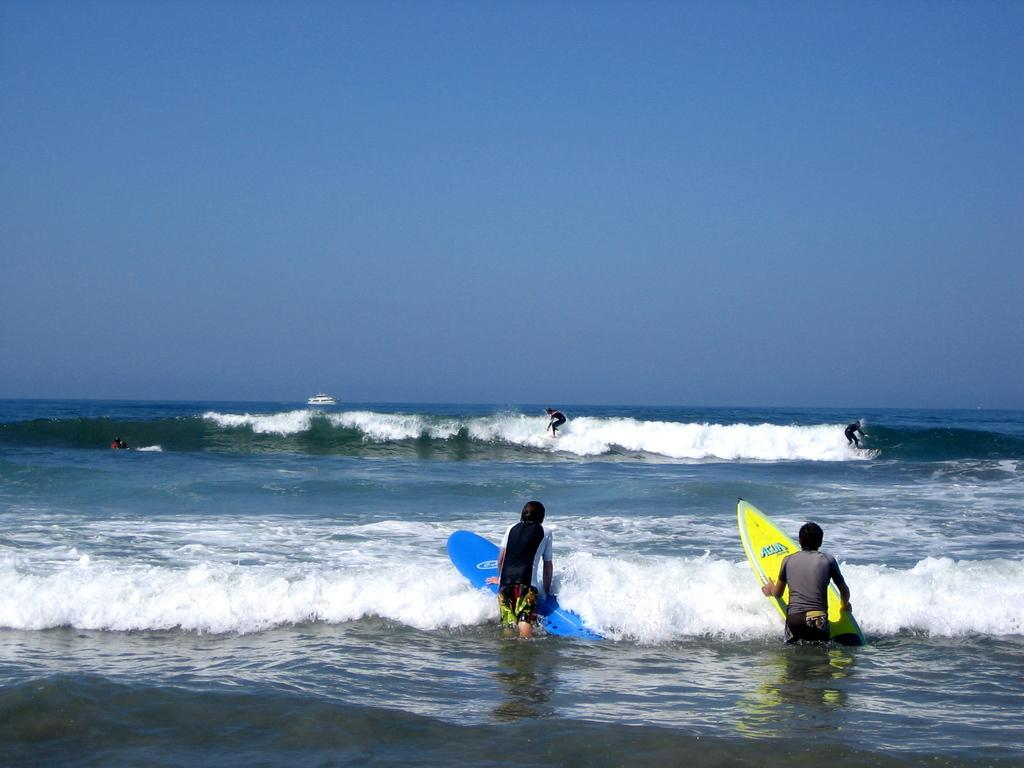What are the two people holding in the image? The two people are holding surfing boards. What are the two people doing with the surfing boards? The two people are surfing on the surface of the sea with the surfing boards. What is the color of the sky in the image? The sky is blue in color. What scent can be detected from the image? There is no scent present in the image, as it is a visual representation. 